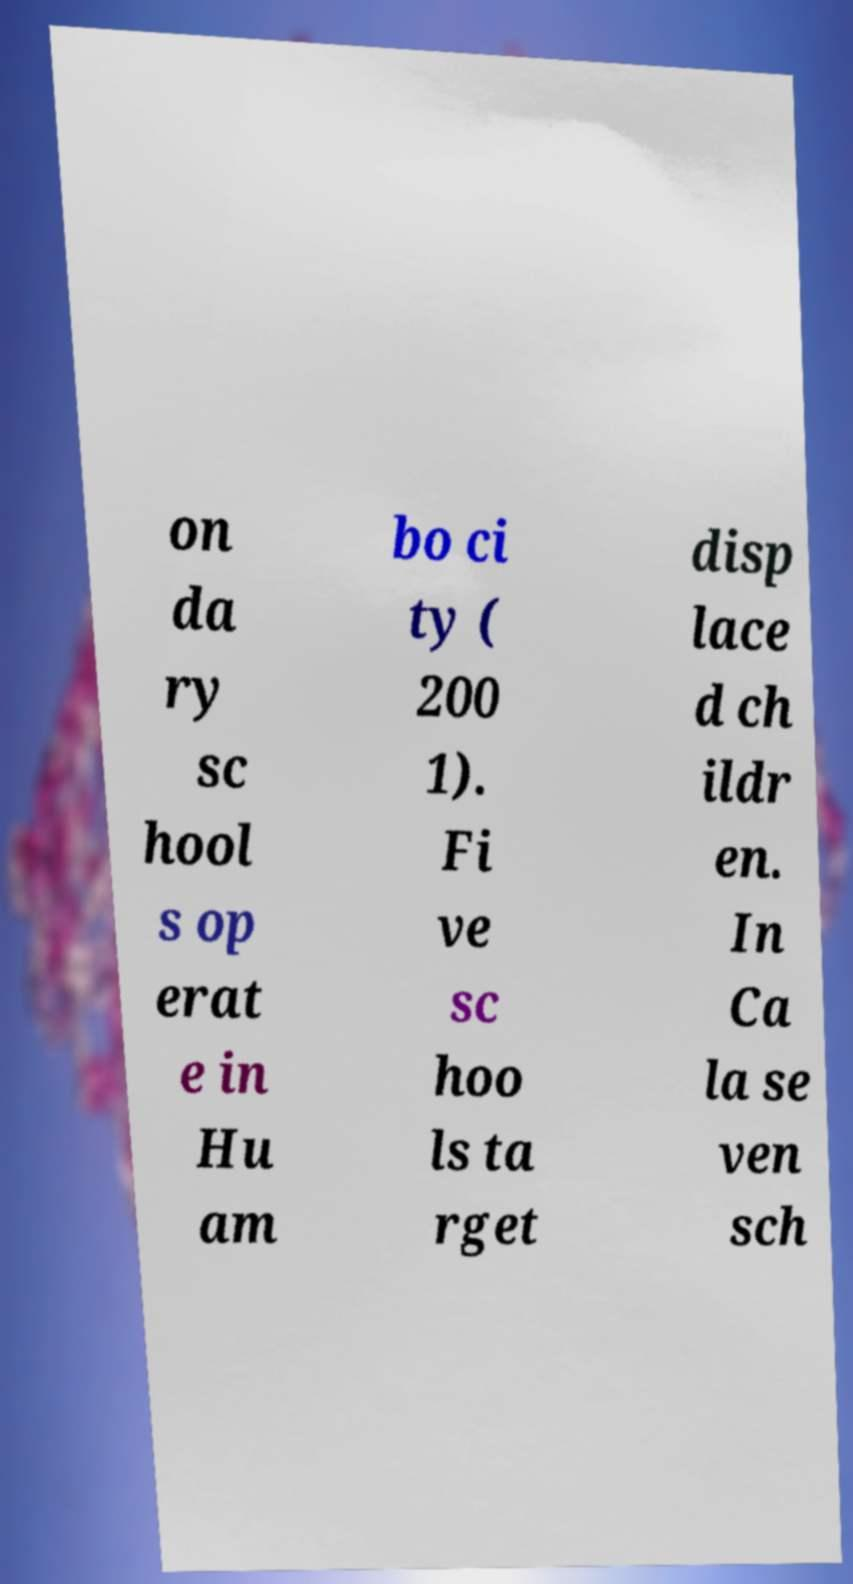Could you extract and type out the text from this image? on da ry sc hool s op erat e in Hu am bo ci ty ( 200 1). Fi ve sc hoo ls ta rget disp lace d ch ildr en. In Ca la se ven sch 